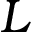Convert formula to latex. <formula><loc_0><loc_0><loc_500><loc_500>L</formula> 